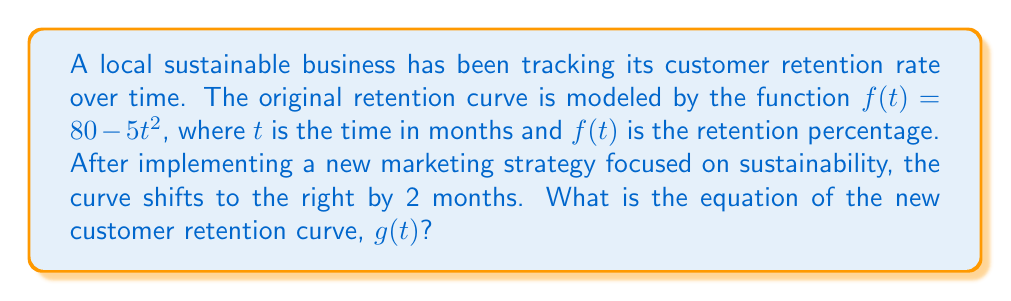Show me your answer to this math problem. To solve this problem, we need to understand horizontal shifts in functions:

1) The general form of a horizontal shift is:
   - For a right shift: $f(t - h)$, where $h$ is positive
   - For a left shift: $f(t + h)$, where $h$ is positive

2) In this case, we have a right shift of 2 months, so $h = 2$.

3) The original function is $f(t) = 80 - 5t^2$.

4) To shift the function 2 units to the right, we replace every $t$ in the original function with $(t - 2)$:

   $g(t) = 80 - 5(t - 2)^2$

5) Expand the squared term:
   $g(t) = 80 - 5(t^2 - 4t + 4)$

6) Distribute the -5:
   $g(t) = 80 - 5t^2 + 20t - 20$

7) Simplify:
   $g(t) = -5t^2 + 20t + 60$

This is the equation of the new customer retention curve after the marketing efforts.
Answer: $g(t) = -5t^2 + 20t + 60$ 